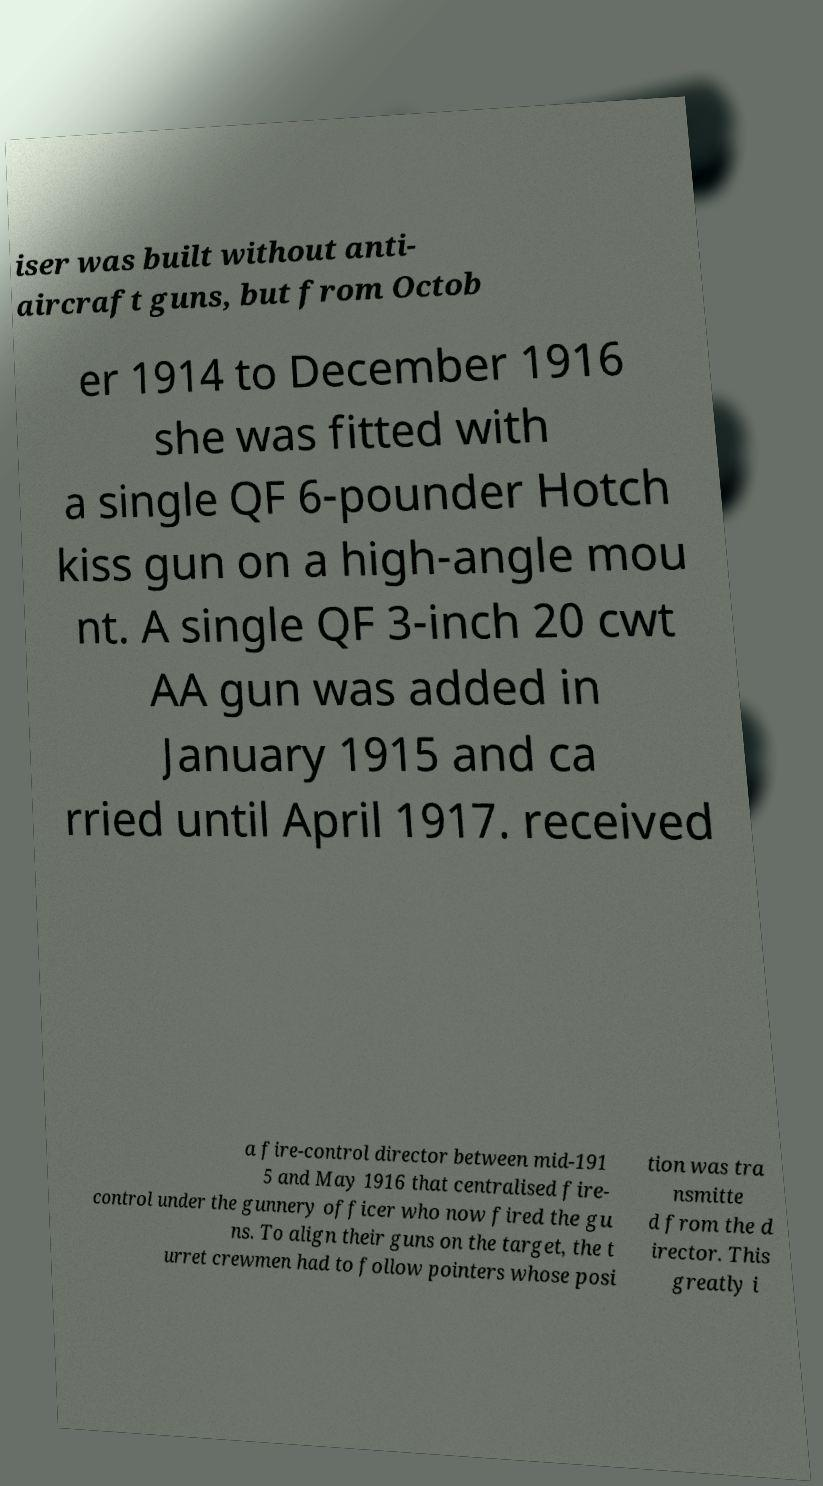Can you read and provide the text displayed in the image?This photo seems to have some interesting text. Can you extract and type it out for me? iser was built without anti- aircraft guns, but from Octob er 1914 to December 1916 she was fitted with a single QF 6-pounder Hotch kiss gun on a high-angle mou nt. A single QF 3-inch 20 cwt AA gun was added in January 1915 and ca rried until April 1917. received a fire-control director between mid-191 5 and May 1916 that centralised fire- control under the gunnery officer who now fired the gu ns. To align their guns on the target, the t urret crewmen had to follow pointers whose posi tion was tra nsmitte d from the d irector. This greatly i 